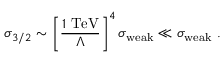<formula> <loc_0><loc_0><loc_500><loc_500>\sigma _ { 3 / 2 } \sim \left [ \frac { 1 T e V } { \Lambda } \right ] ^ { 4 } \sigma _ { w e a k } \ll \sigma _ { w e a k } .</formula> 